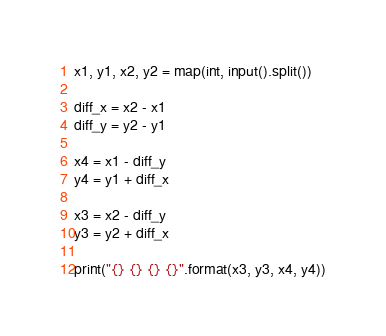Convert code to text. <code><loc_0><loc_0><loc_500><loc_500><_Python_>x1, y1, x2, y2 = map(int, input().split())

diff_x = x2 - x1
diff_y = y2 - y1

x4 = x1 - diff_y
y4 = y1 + diff_x

x3 = x2 - diff_y
y3 = y2 + diff_x

print("{} {} {} {}".format(x3, y3, x4, y4))</code> 